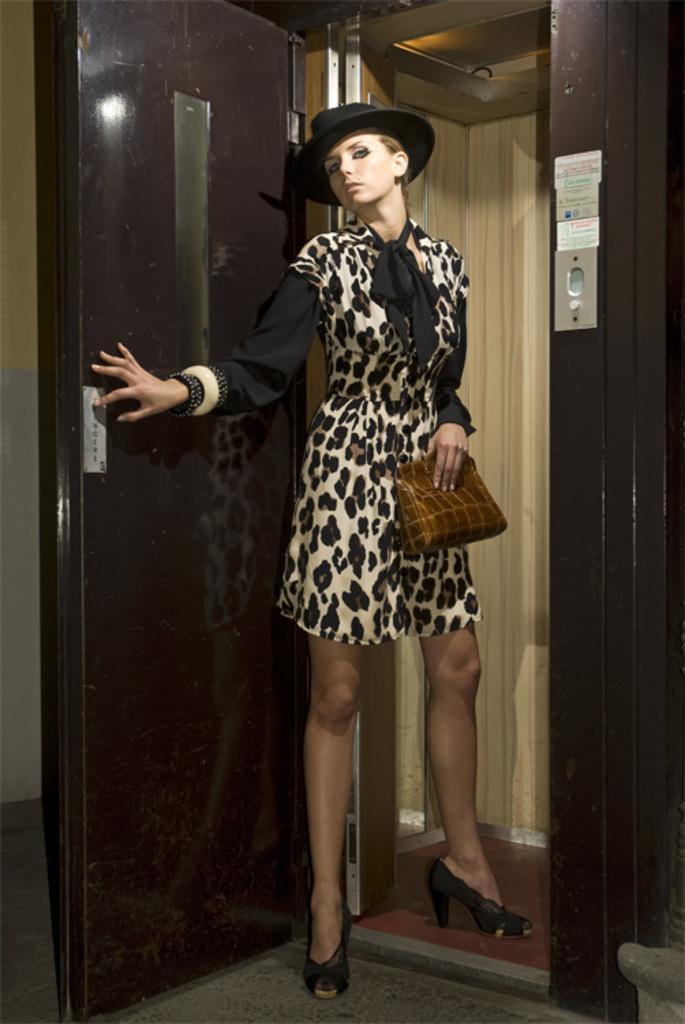Can you describe this image briefly? In this picture there is a woman who is wearing hat, dress, shoe and holding a bag. She is standing near to the door, besides her I can see the cloth which is hanging from this pole. 